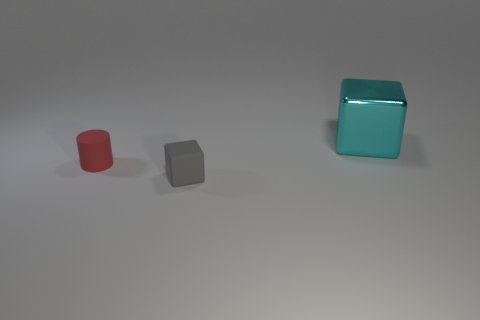Are there any other things that are the same size as the cyan block?
Provide a short and direct response. No. Is there anything else that is the same material as the large cyan block?
Ensure brevity in your answer.  No. Does the big metal thing have the same color as the tiny matte cube?
Make the answer very short. No. There is a tiny object that is the same material as the small gray block; what shape is it?
Your answer should be very brief. Cylinder. What number of other small things are the same shape as the red matte object?
Give a very brief answer. 0. There is a big cyan thing that is behind the cube on the left side of the large cyan cube; what shape is it?
Give a very brief answer. Cube. There is a thing that is behind the red object; is its size the same as the tiny matte block?
Offer a very short reply. No. There is a thing that is both behind the tiny gray rubber object and left of the big cyan cube; what is its size?
Provide a short and direct response. Small. What number of rubber cylinders have the same size as the cyan metal block?
Make the answer very short. 0. There is a cube that is on the left side of the large metallic cube; how many big cyan metallic cubes are to the right of it?
Keep it short and to the point. 1. 